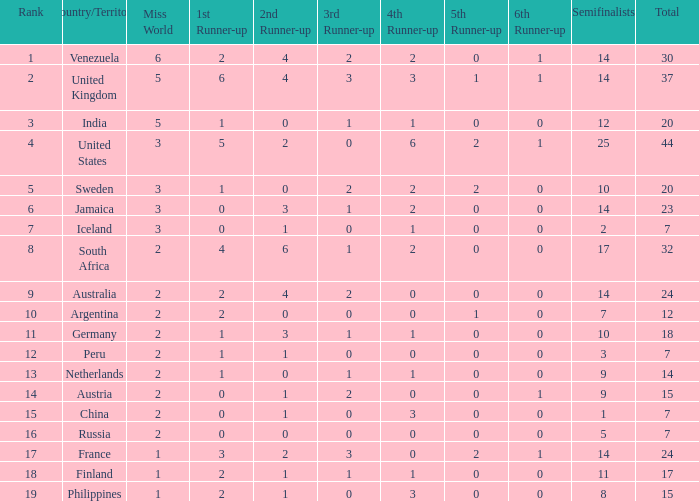What number does venezuela hold in the overall rank? 30.0. 